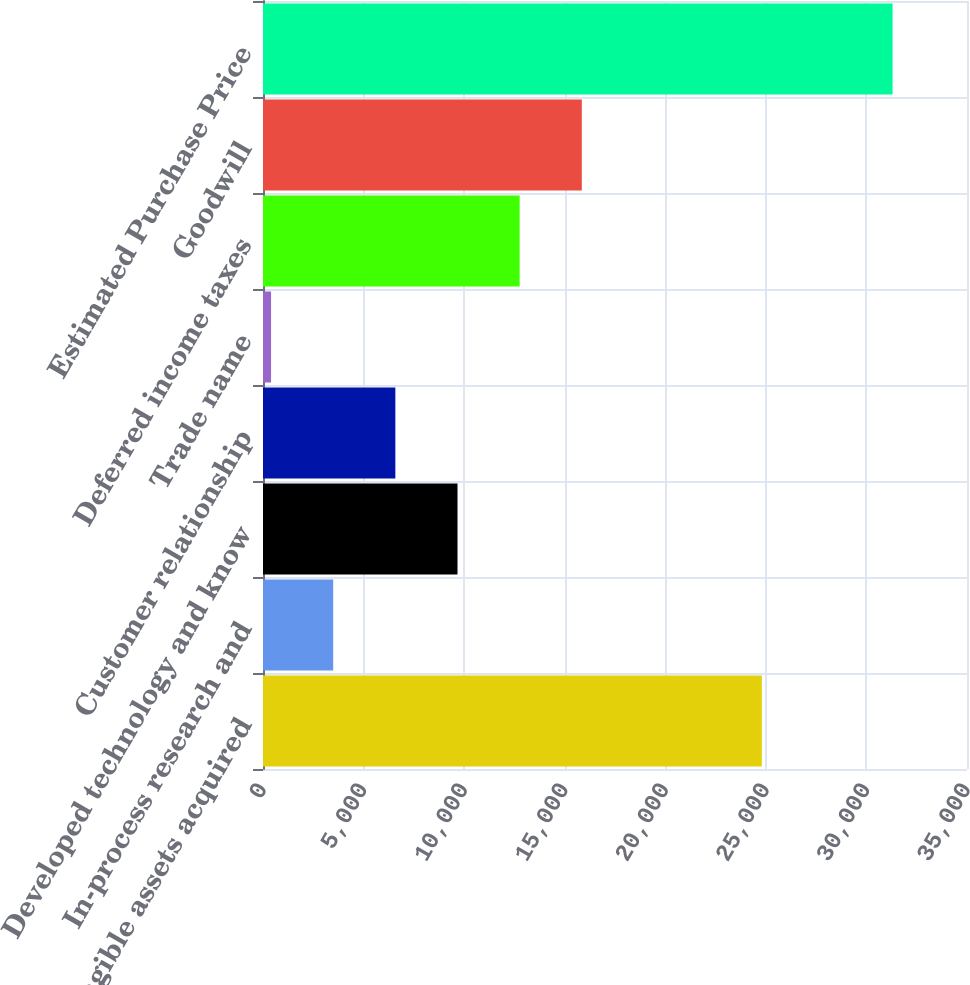<chart> <loc_0><loc_0><loc_500><loc_500><bar_chart><fcel>Net tangible assets acquired<fcel>In-process research and<fcel>Developed technology and know<fcel>Customer relationship<fcel>Trade name<fcel>Deferred income taxes<fcel>Goodwill<fcel>Estimated Purchase Price<nl><fcel>24800<fcel>3490<fcel>9670<fcel>6580<fcel>400<fcel>12760<fcel>15850<fcel>31300<nl></chart> 